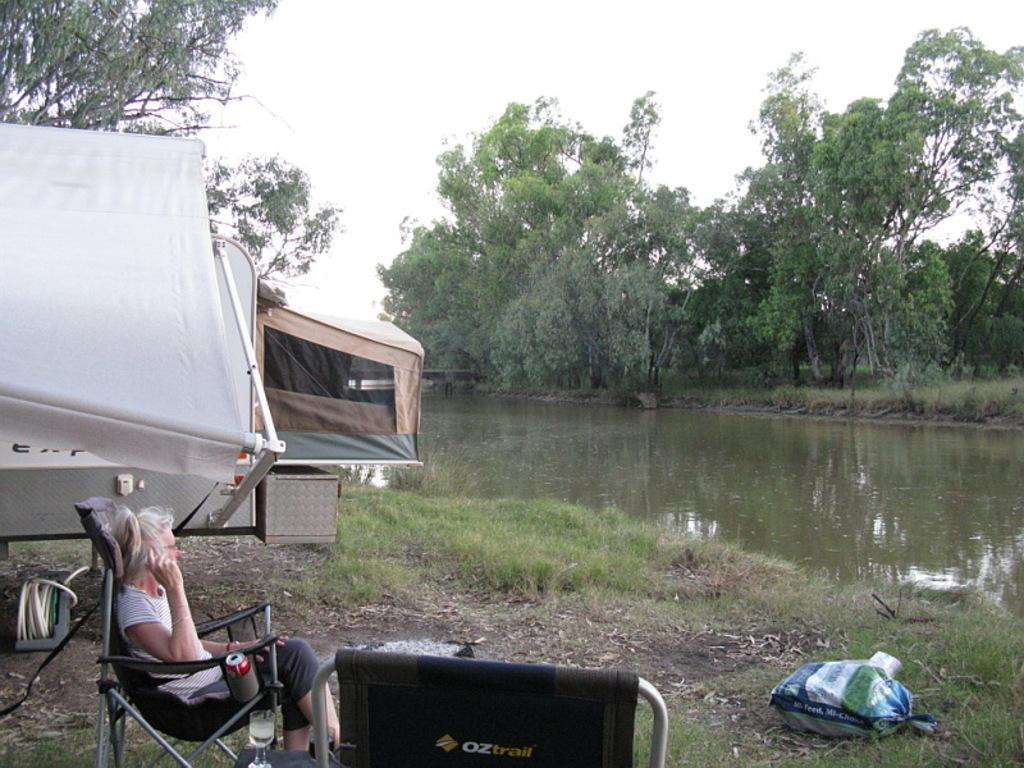What structure is located on the right side of the image? There is a tent on the right side of the image. What is the woman in the image doing? The woman is sitting on a chair in the image. What can be seen in the background of the image? There are trees, the sky, and water visible in the background of the image. What type of spark can be seen coming from the woman's chair in the image? There is no spark present in the image; the woman is simply sitting on a chair. What type of station is visible in the background of the image? There is no station present in the image; the background features trees, the sky, and water. 